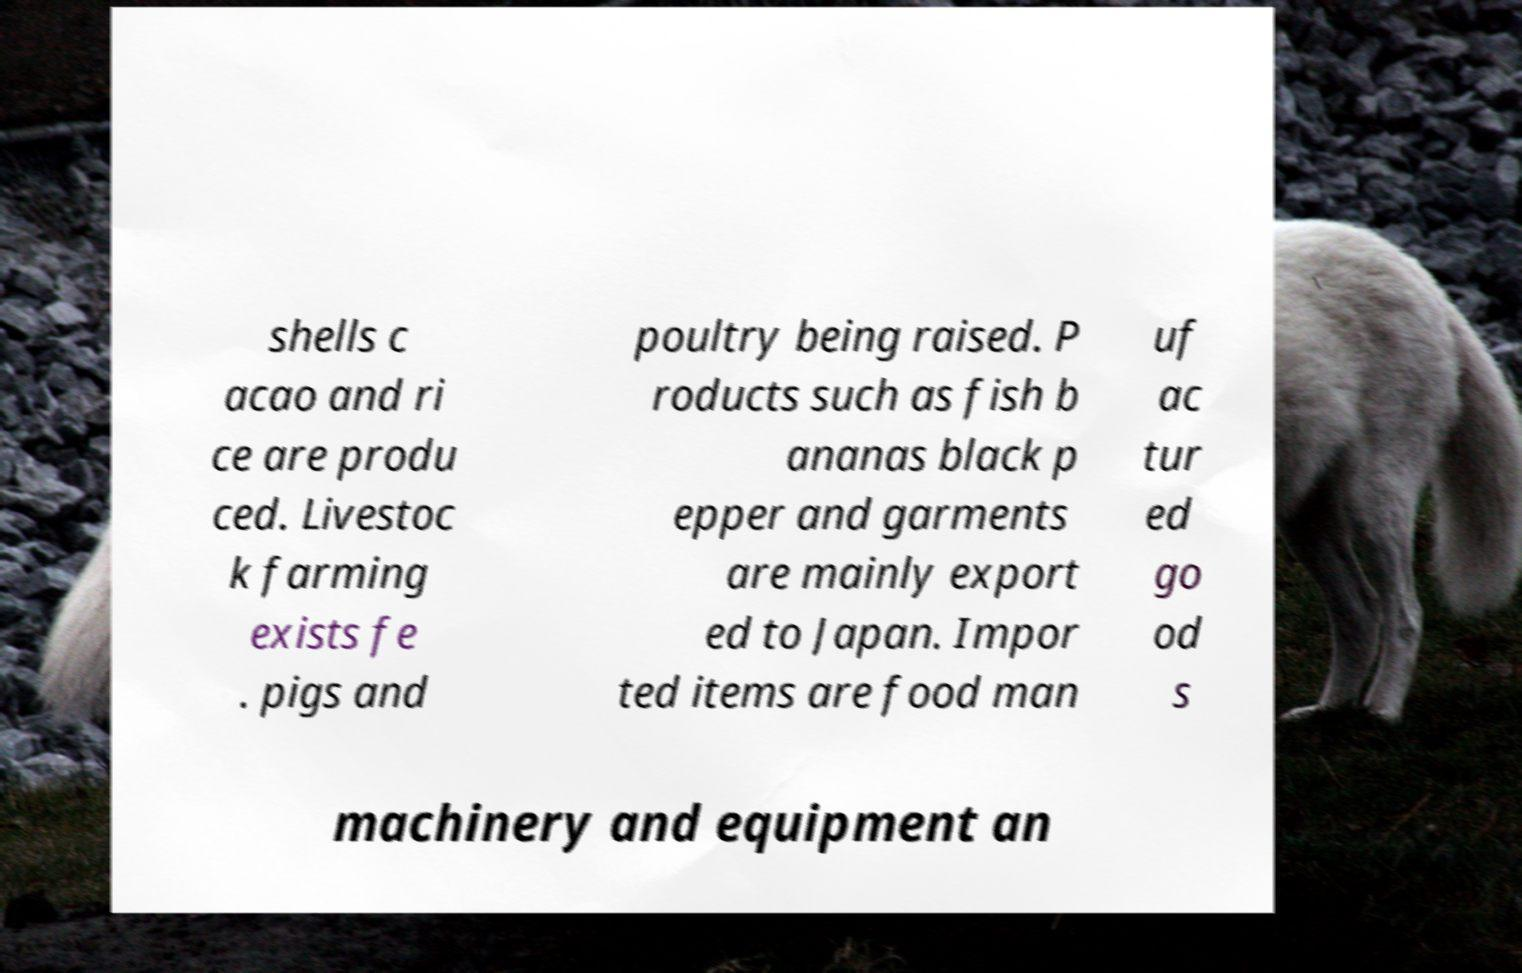Please read and relay the text visible in this image. What does it say? shells c acao and ri ce are produ ced. Livestoc k farming exists fe . pigs and poultry being raised. P roducts such as fish b ananas black p epper and garments are mainly export ed to Japan. Impor ted items are food man uf ac tur ed go od s machinery and equipment an 